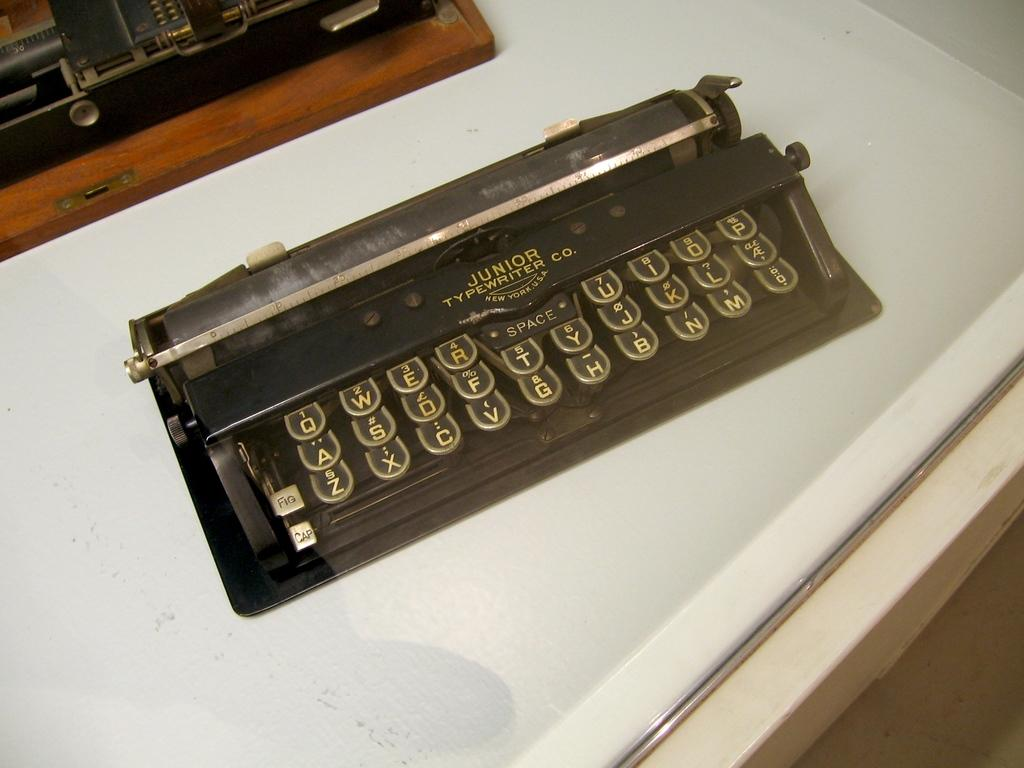<image>
Relay a brief, clear account of the picture shown. Junior Typewriter Company is the manufacturer of the old typewriter on display. 